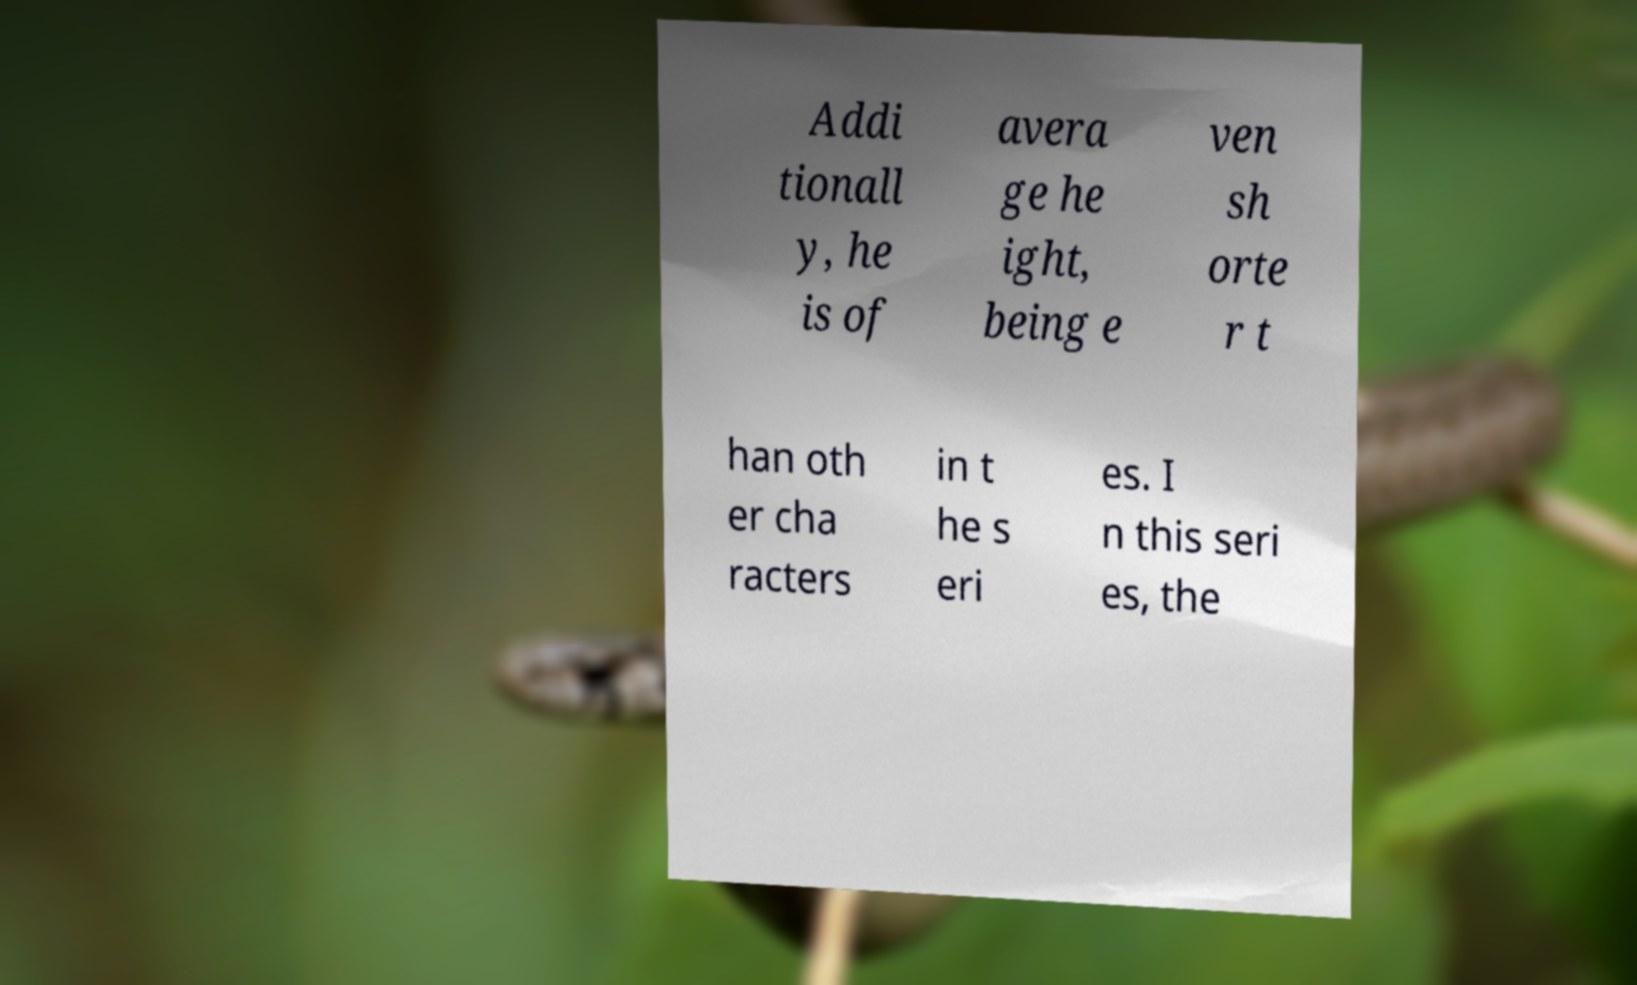Could you assist in decoding the text presented in this image and type it out clearly? Addi tionall y, he is of avera ge he ight, being e ven sh orte r t han oth er cha racters in t he s eri es. I n this seri es, the 